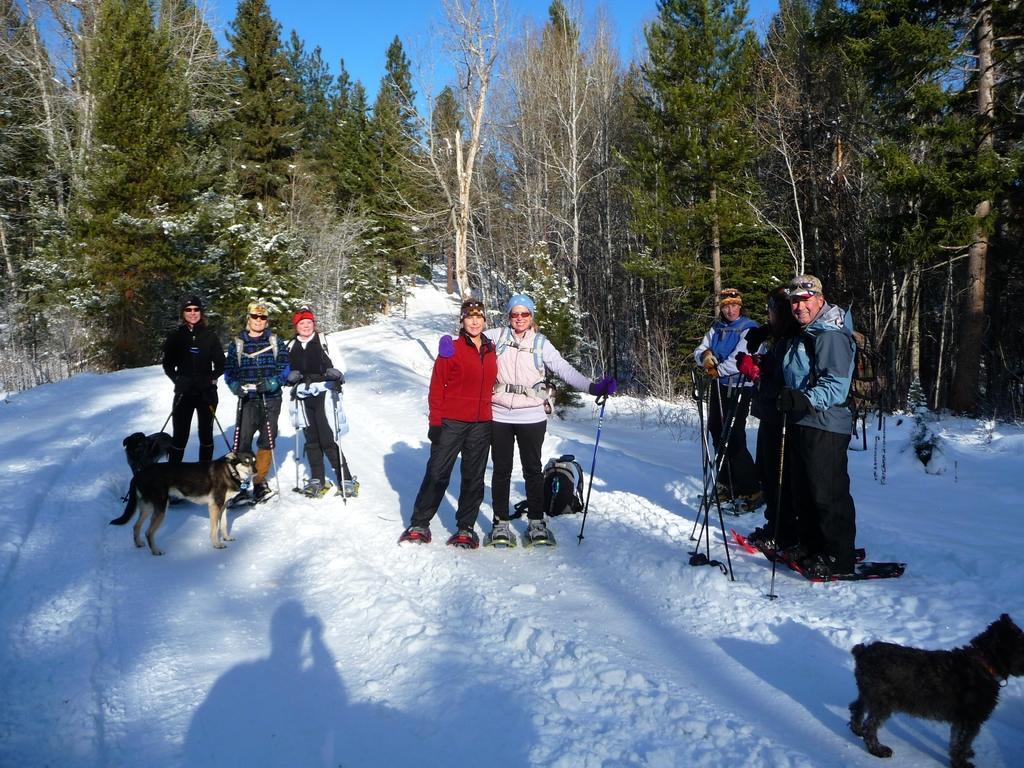In one or two sentences, can you explain what this image depicts? There are group of people standing with the skiboards and holding ski poles in their hands. This looks like a bag. I can see three dogs standing. This is the snow. These are the trees. 